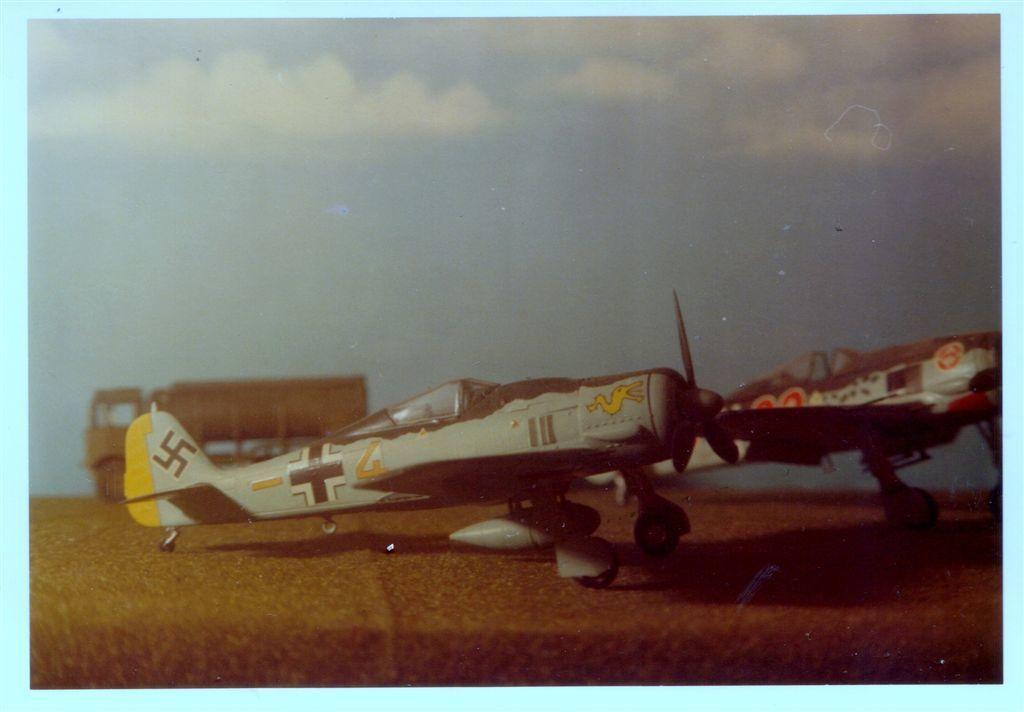How would you summarize this image in a sentence or two? In this image we can see a painting, in the painting we can see an aircraft, behind the aircraft there is a truck. 